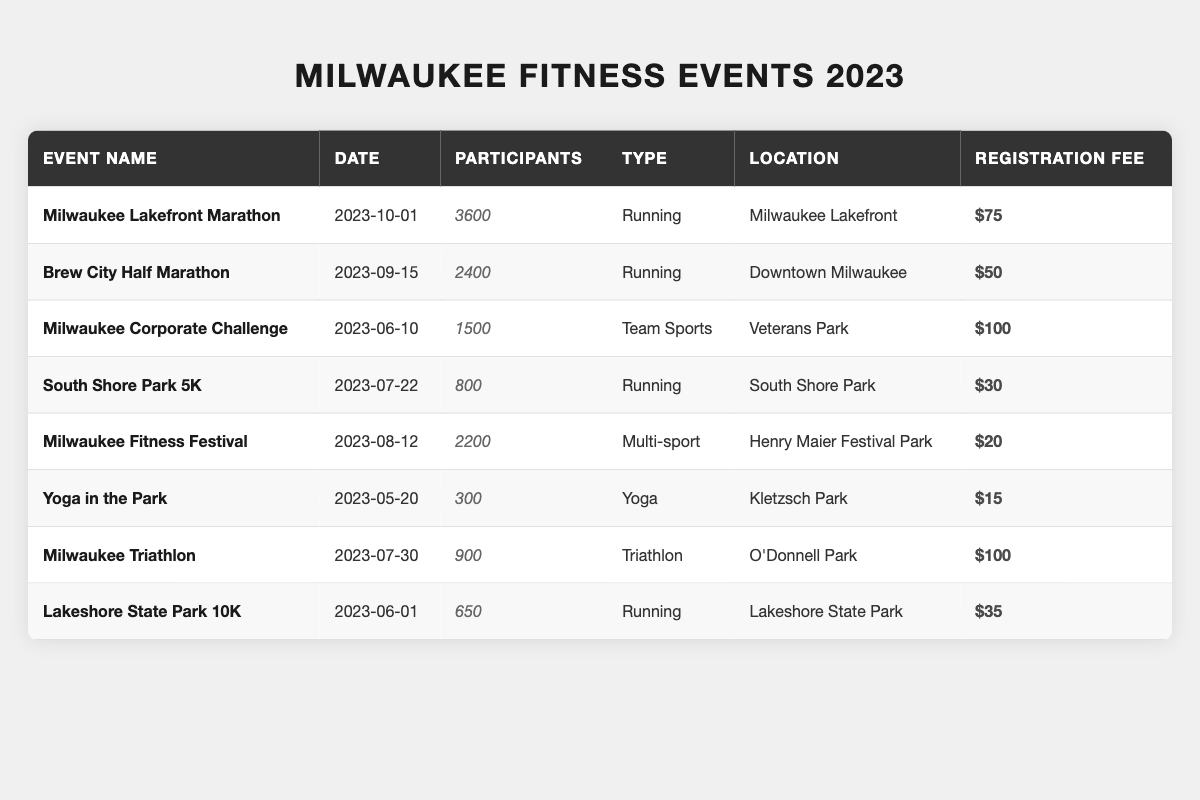What is the total number of participants in all fitness events listed? To find the total number of participants, add the participants from each event: 3600 + 2400 + 1500 + 800 + 2200 + 300 + 900 + 650 = 12600.
Answer: 12600 Which event had the highest number of participants? The event with the highest number of participants is the Milwaukee Lakefront Marathon, which had 3600 participants.
Answer: Milwaukee Lakefront Marathon Is the registration fee for the Milwaukee Triathlon higher than the fee for the South Shore Park 5K? The registration fee for the Milwaukee Triathlon is $100, and for the South Shore Park 5K, it is $30. Since $100 is greater than $30, the statement is true.
Answer: Yes What is the average number of participants across all events? To get the average, sum all participants (12600) and divide by the number of events (8): 12600 / 8 = 1575.
Answer: 1575 Which event type had the fewest participants? The event with the fewest participants is Yoga in the Park, with only 300 participants, making it the smallest.
Answer: Yoga What is the difference in registration fees between the Milwaukee Lakefront Marathon and the Milwaukee Fitness Festival? The registration fee for the Milwaukee Lakefront Marathon is $75 and for the Milwaukee Fitness Festival, it is $20. The difference is $75 - $20 = $55.
Answer: $55 How many running events had more than 1000 participants? The running events with more than 1000 participants are the Milwaukee Lakefront Marathon (3600), Brew City Half Marathon (2400), and Milwaukee Triathlon (900), making a total of 3 events.
Answer: 3 What is the total registration fee collected from all participants in the Milwaukee Fitness Festival? The registration fee for the Milwaukee Fitness Festival is $20 and it had 2200 participants. Thus, the total fee collected is 2200 * $20 = $44000.
Answer: $44000 Are there more participants in the Brew City Half Marathon than in the Milwaukee Corporate Challenge? The Brew City Half Marathon had 2400 participants, while the Milwaukee Corporate Challenge had 1500. Since 2400 is greater than 1500, the statement is true.
Answer: Yes What is the median number of participants in all the events? Listing the participants in ascending order: 300, 650, 800, 900, 1500, 2200, 2400, 3600. The median of these 8 numbers is the average of the 4th and 5th (900 and 1500), which equals (900 + 1500) / 2 = 1200.
Answer: 1200 